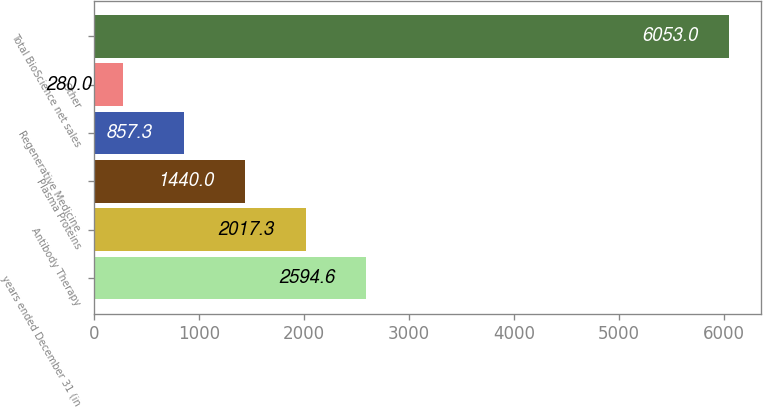<chart> <loc_0><loc_0><loc_500><loc_500><bar_chart><fcel>years ended December 31 (in<fcel>Antibody Therapy<fcel>Plasma Proteins<fcel>Regenerative Medicine<fcel>Other<fcel>Total BioScience net sales<nl><fcel>2594.6<fcel>2017.3<fcel>1440<fcel>857.3<fcel>280<fcel>6053<nl></chart> 